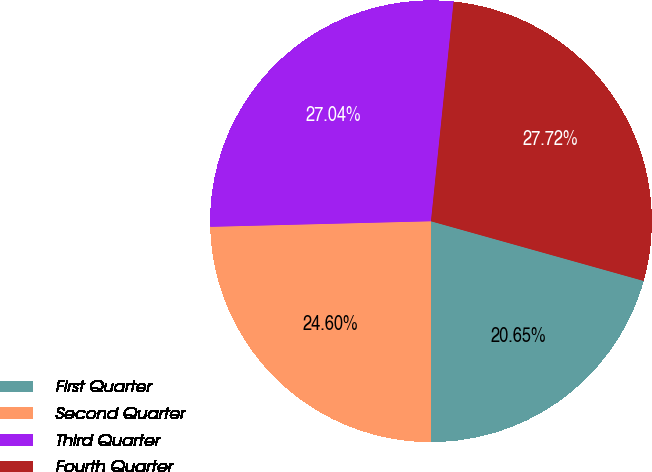Convert chart. <chart><loc_0><loc_0><loc_500><loc_500><pie_chart><fcel>First Quarter<fcel>Second Quarter<fcel>Third Quarter<fcel>Fourth Quarter<nl><fcel>20.65%<fcel>24.6%<fcel>27.04%<fcel>27.72%<nl></chart> 